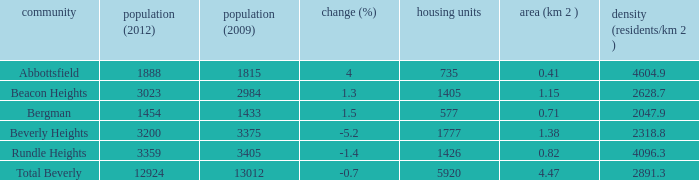What is the density of an area that is 1.38km and has a population more than 12924? 0.0. 